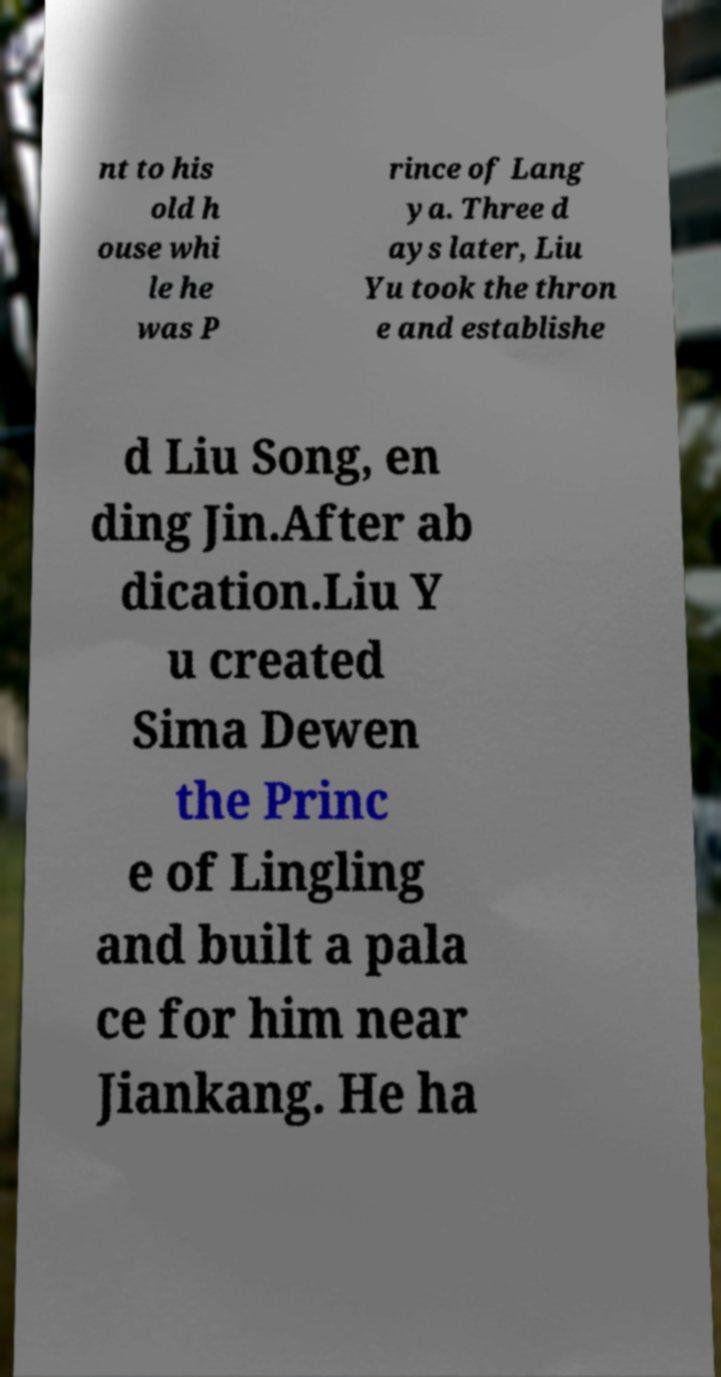Please read and relay the text visible in this image. What does it say? nt to his old h ouse whi le he was P rince of Lang ya. Three d ays later, Liu Yu took the thron e and establishe d Liu Song, en ding Jin.After ab dication.Liu Y u created Sima Dewen the Princ e of Lingling and built a pala ce for him near Jiankang. He ha 